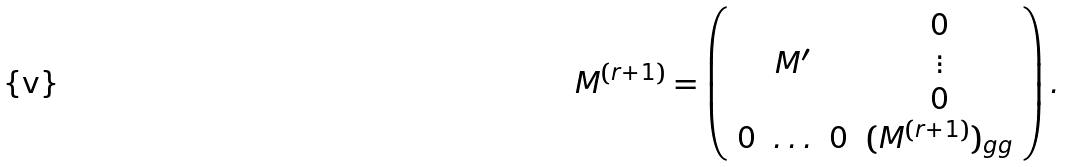<formula> <loc_0><loc_0><loc_500><loc_500>M ^ { ( r + 1 ) } = \left ( \begin{array} { c c c c } & & & 0 \\ & M ^ { \prime } & & \vdots \\ & & & 0 \\ 0 & \hdots & 0 & ( M ^ { ( r + 1 ) } ) _ { g g } \\ \end{array} \right ) .</formula> 